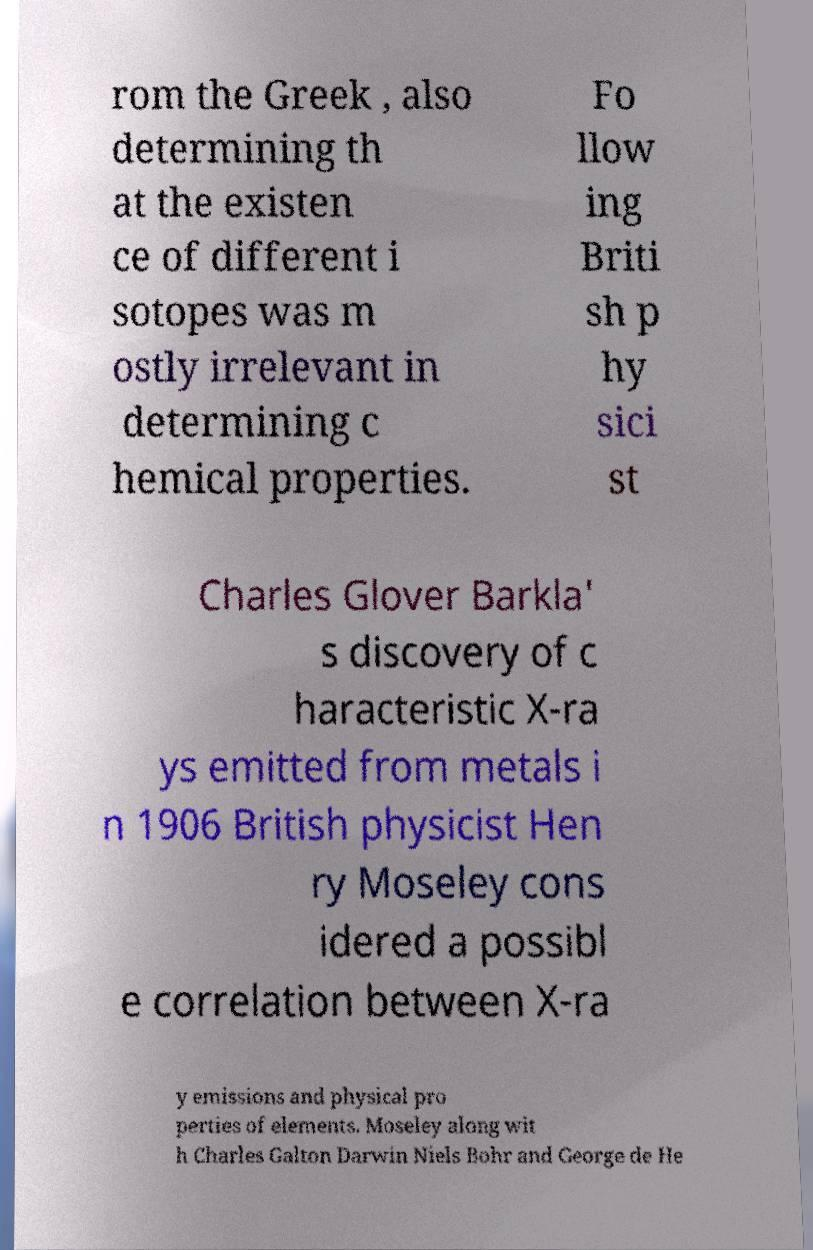Please identify and transcribe the text found in this image. rom the Greek , also determining th at the existen ce of different i sotopes was m ostly irrelevant in determining c hemical properties. Fo llow ing Briti sh p hy sici st Charles Glover Barkla' s discovery of c haracteristic X-ra ys emitted from metals i n 1906 British physicist Hen ry Moseley cons idered a possibl e correlation between X-ra y emissions and physical pro perties of elements. Moseley along wit h Charles Galton Darwin Niels Bohr and George de He 